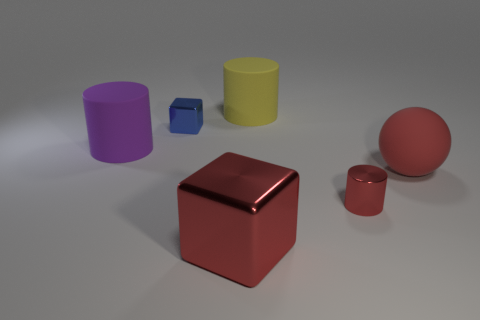The red shiny object that is the same shape as the small blue object is what size?
Provide a succinct answer. Large. What shape is the small shiny object that is on the right side of the large rubber object that is behind the small blue shiny cube?
Offer a terse response. Cylinder. What is the size of the blue metallic cube?
Provide a short and direct response. Small. What is the shape of the tiny blue shiny thing?
Your answer should be compact. Cube. Does the large red matte object have the same shape as the small thing right of the tiny metallic cube?
Provide a short and direct response. No. There is a big rubber object that is behind the large purple rubber cylinder; does it have the same shape as the red rubber thing?
Provide a succinct answer. No. What number of objects are to the right of the red block and on the left side of the red block?
Give a very brief answer. 0. What number of other things are there of the same size as the yellow object?
Keep it short and to the point. 3. Is the number of yellow rubber objects that are on the right side of the metal cylinder the same as the number of blue shiny objects?
Provide a short and direct response. No. Does the metallic cube behind the red metallic block have the same color as the rubber cylinder in front of the yellow rubber cylinder?
Offer a very short reply. No. 